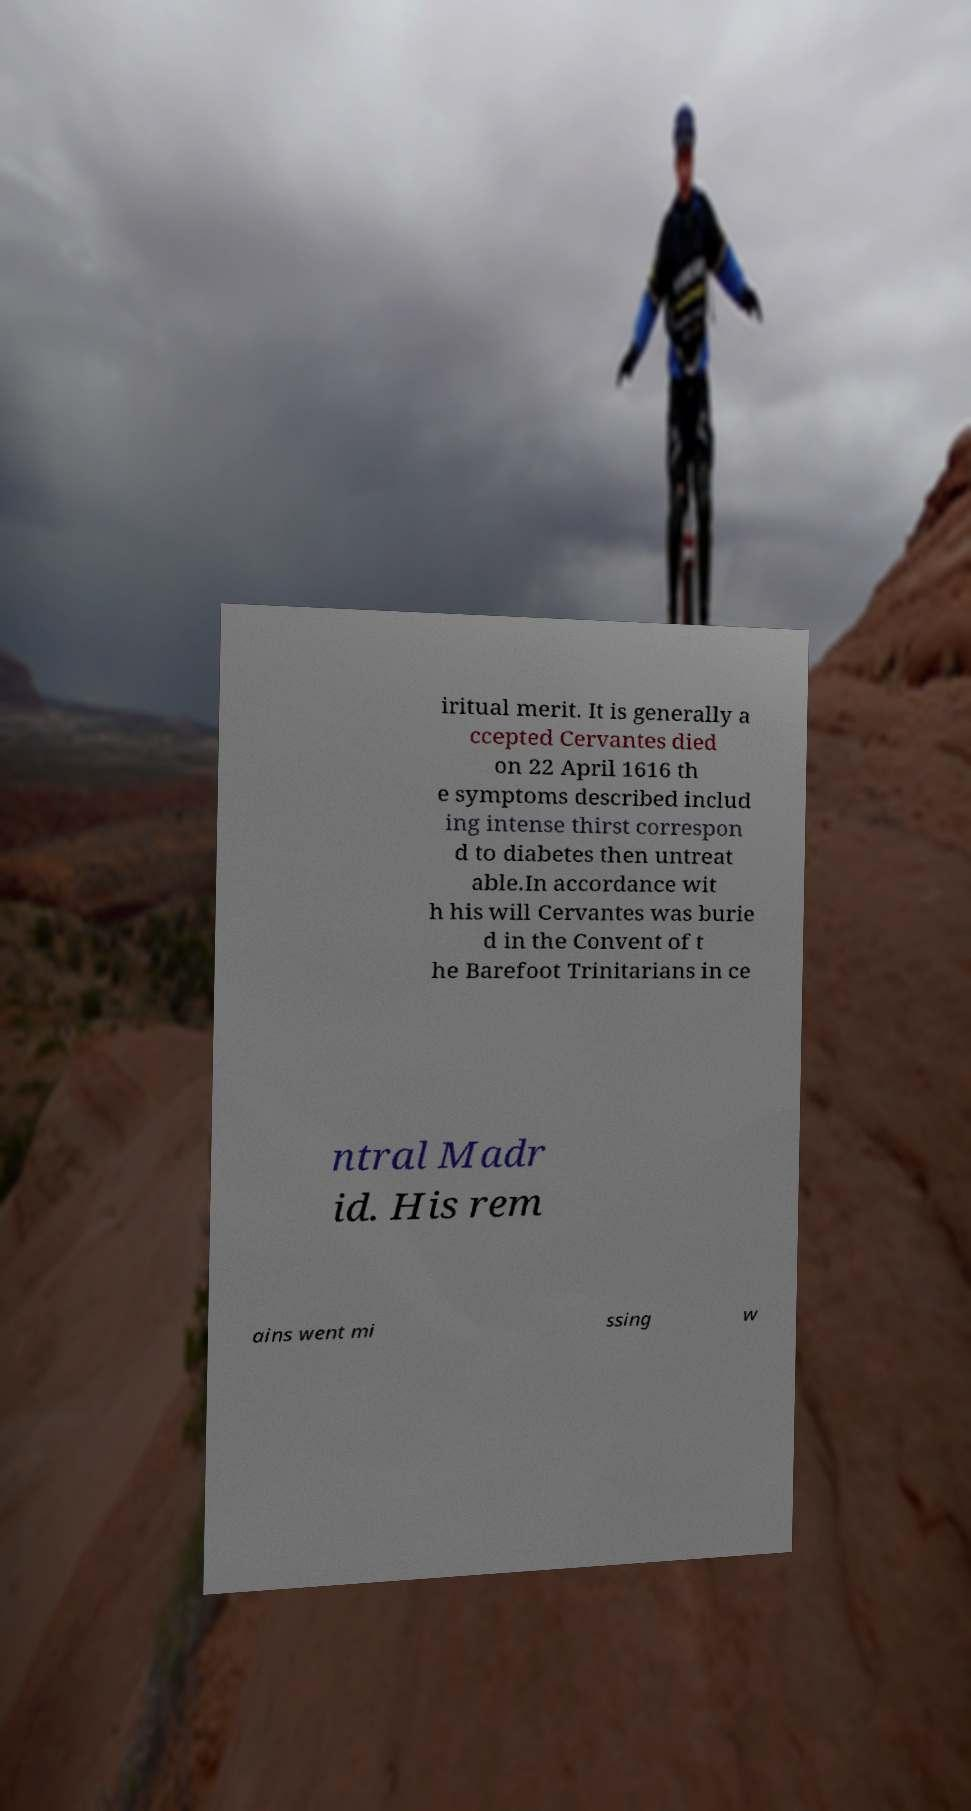For documentation purposes, I need the text within this image transcribed. Could you provide that? iritual merit. It is generally a ccepted Cervantes died on 22 April 1616 th e symptoms described includ ing intense thirst correspon d to diabetes then untreat able.In accordance wit h his will Cervantes was burie d in the Convent of t he Barefoot Trinitarians in ce ntral Madr id. His rem ains went mi ssing w 